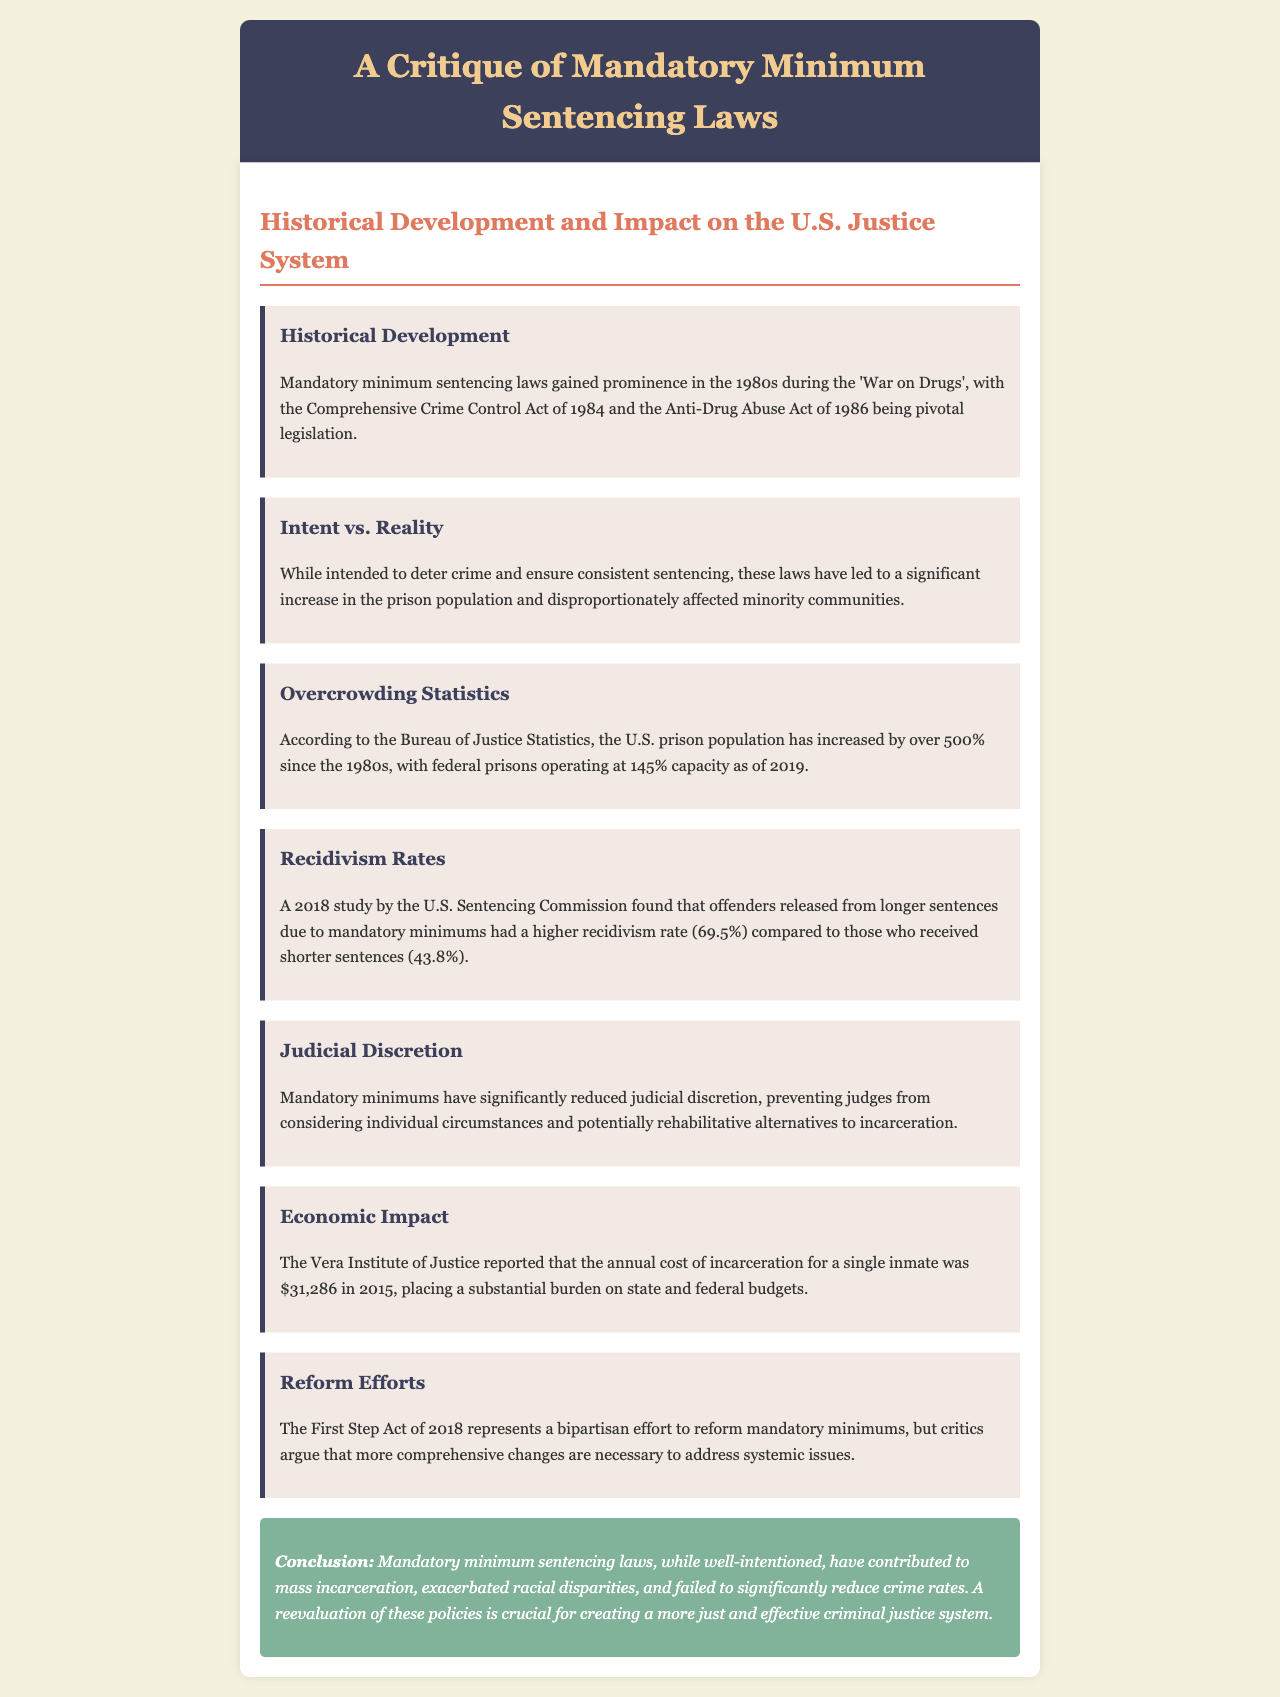What legislative acts were pivotal in the development of mandatory minimum sentencing laws? The document lists the Comprehensive Crime Control Act of 1984 and the Anti-Drug Abuse Act of 1986 as pivotal legislation.
Answer: Comprehensive Crime Control Act of 1984 and Anti-Drug Abuse Act of 1986 What percentage increase has the U.S. prison population experienced since the 1980s? According to the Bureau of Justice Statistics, the document states that the U.S. prison population has increased by over 500% since the 1980s.
Answer: Over 500% What was the recidivism rate for offenders released from longer sentences due to mandatory minimums according to the 2018 study? The document mentions a recidivism rate of 69.5% for offenders released from longer sentences.
Answer: 69.5% What is the annual cost of incarceration for a single inmate as reported in 2015? The Vera Institute of Justice provided the figure of $31,286 for the annual cost of incarceration per inmate.
Answer: $31,286 What impact have mandatory minimums had on judicial discretion? The document states that mandatory minimums have significantly reduced judicial discretion.
Answer: Significantly reduced What legislative effort represents a response to mandatory minimum sentencing laws? The document refers to the First Step Act of 2018 as a bipartisan effort to reform mandatory minimums.
Answer: First Step Act of 2018 How does the document conclude regarding mandatory minimum sentencing laws? The conclusion notes that these laws have contributed to mass incarceration, exacerbated racial disparities, and failed to significantly reduce crime rates.
Answer: Mass incarceration and exacerbated racial disparities 